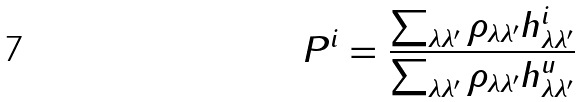Convert formula to latex. <formula><loc_0><loc_0><loc_500><loc_500>P ^ { i } = { \frac { \sum _ { \lambda \lambda ^ { \prime } } \rho _ { \lambda \lambda ^ { \prime } } h ^ { i } _ { \lambda \lambda ^ { \prime } } } { \sum _ { \lambda \lambda ^ { \prime } } \rho _ { \lambda \lambda ^ { \prime } } h ^ { u } _ { \lambda \lambda ^ { \prime } } } }</formula> 